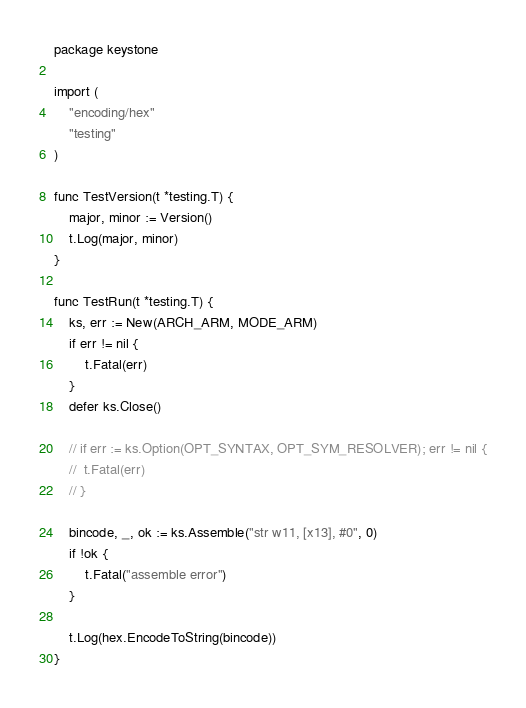Convert code to text. <code><loc_0><loc_0><loc_500><loc_500><_Go_>package keystone

import (
	"encoding/hex"
	"testing"
)

func TestVersion(t *testing.T) {
	major, minor := Version()
	t.Log(major, minor)
}

func TestRun(t *testing.T) {
	ks, err := New(ARCH_ARM, MODE_ARM)
	if err != nil {
		t.Fatal(err)
	}
	defer ks.Close()

	// if err := ks.Option(OPT_SYNTAX, OPT_SYM_RESOLVER); err != nil {
	// 	t.Fatal(err)
	// }

	bincode, _, ok := ks.Assemble("str w11, [x13], #0", 0)
	if !ok {
		t.Fatal("assemble error")
	}

	t.Log(hex.EncodeToString(bincode))
}
</code> 